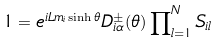Convert formula to latex. <formula><loc_0><loc_0><loc_500><loc_500>1 = e ^ { i L m _ { i } \sinh \theta } D _ { i \alpha } ^ { \pm } ( \theta ) \prod \nolimits _ { l = 1 } ^ { N } S _ { i l }</formula> 